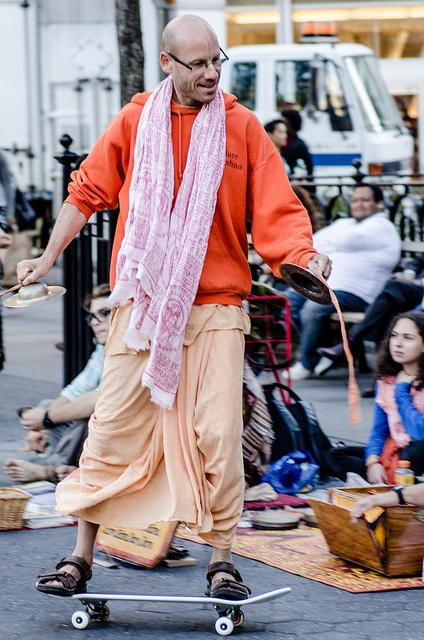In what year was his organization founded in New York City? 1966 